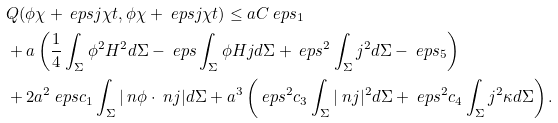<formula> <loc_0><loc_0><loc_500><loc_500>& Q ( \phi \chi + \ e p s j \chi t , \phi \chi + \ e p s j \chi t ) \leq a C \ e p s _ { 1 } \\ & + a \left ( \frac { 1 } { 4 } \int _ { \Sigma } \phi ^ { 2 } H ^ { 2 } d \Sigma - \ e p s \int _ { \Sigma } \phi H j d \Sigma + \ e p s ^ { 2 } \int _ { \Sigma } j ^ { 2 } d \Sigma - \ e p s _ { 5 } \right ) \\ & + 2 a ^ { 2 } \ e p s c _ { 1 } \int _ { \Sigma } | \ n \phi \cdot \ n j | d \Sigma + a ^ { 3 } \left ( \ e p s ^ { 2 } c _ { 3 } \int _ { \Sigma } | \ n j | ^ { 2 } d \Sigma + \ e p s ^ { 2 } c _ { 4 } \int _ { \Sigma } j ^ { 2 } \kappa d \Sigma \right ) .</formula> 